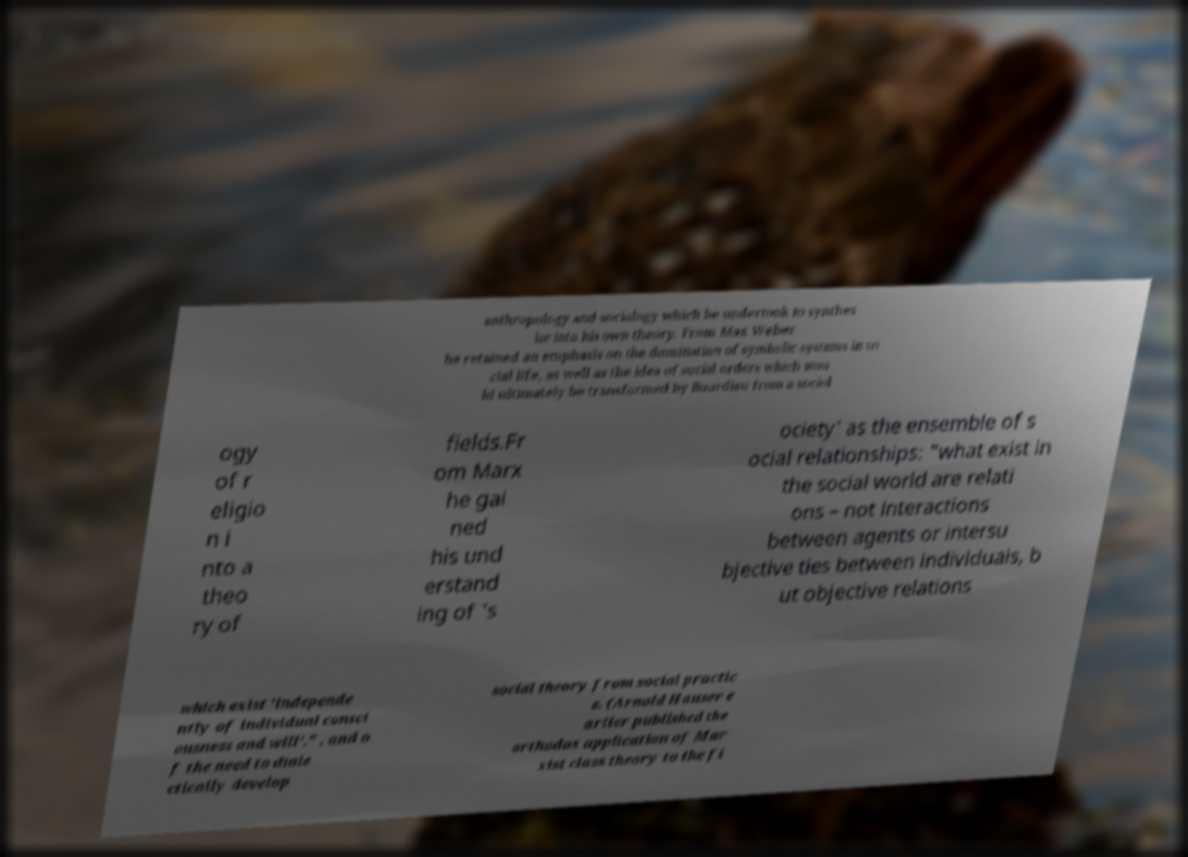Please read and relay the text visible in this image. What does it say? anthropology and sociology which he undertook to synthes ize into his own theory. From Max Weber he retained an emphasis on the domination of symbolic systems in so cial life, as well as the idea of social orders which wou ld ultimately be transformed by Bourdieu from a sociol ogy of r eligio n i nto a theo ry of fields.Fr om Marx he gai ned his und erstand ing of 's ociety' as the ensemble of s ocial relationships: "what exist in the social world are relati ons – not interactions between agents or intersu bjective ties between individuals, b ut objective relations which exist 'independe ntly of individual consci ousness and will'." , and o f the need to diale ctically develop social theory from social practic e. (Arnold Hauser e arlier published the orthodox application of Mar xist class theory to the fi 